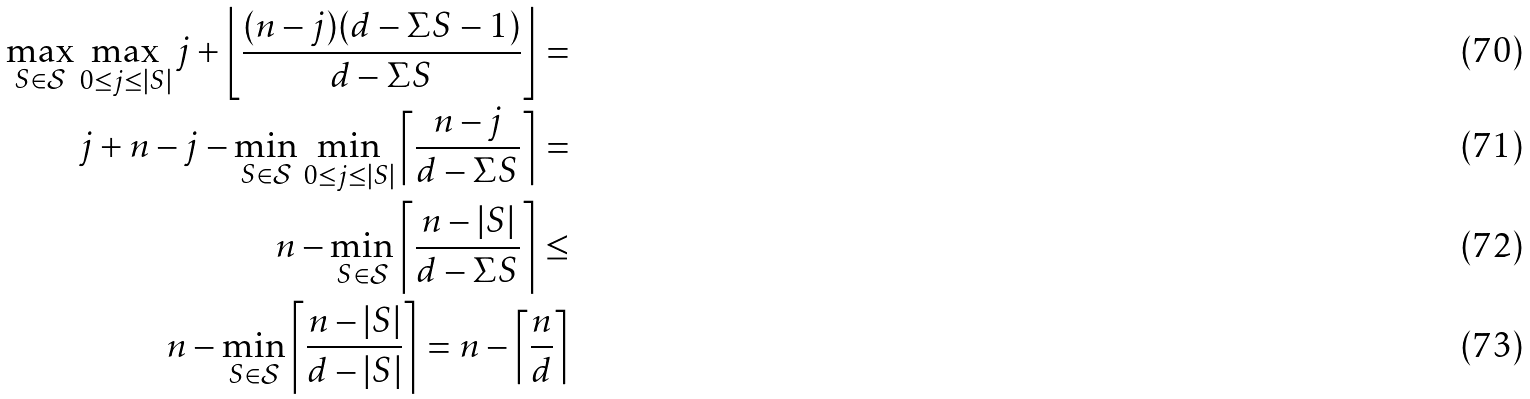Convert formula to latex. <formula><loc_0><loc_0><loc_500><loc_500>\max _ { S \in { \mathcal { S } } } \max _ { 0 \leq j \leq | S | } j + \left \lfloor \frac { ( n - j ) ( d - \Sigma S - 1 ) } { d - \Sigma S } \right \rfloor = \\ j + n - j - \min _ { S \in { \mathcal { S } } } \min _ { 0 \leq j \leq | S | } \left \lceil \frac { n - j } { d - \Sigma S } \right \rceil = \\ n - \min _ { S \in { \mathcal { S } } } \left \lceil \frac { n - | S | } { d - \Sigma S } \right \rceil \leq \\ n - \min _ { S \in { \mathcal { S } } } \left \lceil \frac { n - | S | } { d - | S | } \right \rceil = n - \left \lceil \frac { n } { d } \right \rceil</formula> 